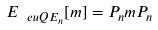Convert formula to latex. <formula><loc_0><loc_0><loc_500><loc_500>E _ { \ e u { Q E } _ { n } } [ m ] = P _ { n } m P _ { n }</formula> 